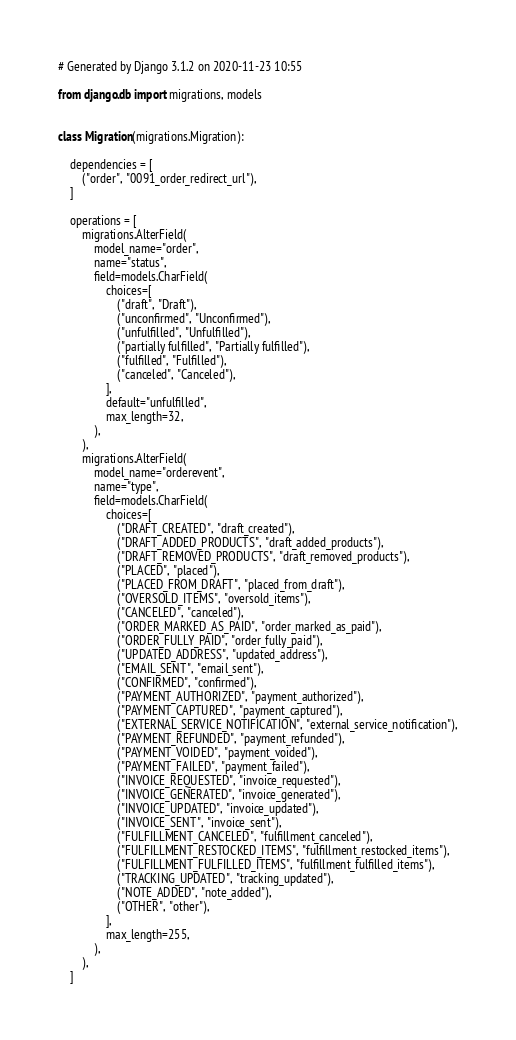<code> <loc_0><loc_0><loc_500><loc_500><_Python_># Generated by Django 3.1.2 on 2020-11-23 10:55

from django.db import migrations, models


class Migration(migrations.Migration):

    dependencies = [
        ("order", "0091_order_redirect_url"),
    ]

    operations = [
        migrations.AlterField(
            model_name="order",
            name="status",
            field=models.CharField(
                choices=[
                    ("draft", "Draft"),
                    ("unconfirmed", "Unconfirmed"),
                    ("unfulfilled", "Unfulfilled"),
                    ("partially fulfilled", "Partially fulfilled"),
                    ("fulfilled", "Fulfilled"),
                    ("canceled", "Canceled"),
                ],
                default="unfulfilled",
                max_length=32,
            ),
        ),
        migrations.AlterField(
            model_name="orderevent",
            name="type",
            field=models.CharField(
                choices=[
                    ("DRAFT_CREATED", "draft_created"),
                    ("DRAFT_ADDED_PRODUCTS", "draft_added_products"),
                    ("DRAFT_REMOVED_PRODUCTS", "draft_removed_products"),
                    ("PLACED", "placed"),
                    ("PLACED_FROM_DRAFT", "placed_from_draft"),
                    ("OVERSOLD_ITEMS", "oversold_items"),
                    ("CANCELED", "canceled"),
                    ("ORDER_MARKED_AS_PAID", "order_marked_as_paid"),
                    ("ORDER_FULLY_PAID", "order_fully_paid"),
                    ("UPDATED_ADDRESS", "updated_address"),
                    ("EMAIL_SENT", "email_sent"),
                    ("CONFIRMED", "confirmed"),
                    ("PAYMENT_AUTHORIZED", "payment_authorized"),
                    ("PAYMENT_CAPTURED", "payment_captured"),
                    ("EXTERNAL_SERVICE_NOTIFICATION", "external_service_notification"),
                    ("PAYMENT_REFUNDED", "payment_refunded"),
                    ("PAYMENT_VOIDED", "payment_voided"),
                    ("PAYMENT_FAILED", "payment_failed"),
                    ("INVOICE_REQUESTED", "invoice_requested"),
                    ("INVOICE_GENERATED", "invoice_generated"),
                    ("INVOICE_UPDATED", "invoice_updated"),
                    ("INVOICE_SENT", "invoice_sent"),
                    ("FULFILLMENT_CANCELED", "fulfillment_canceled"),
                    ("FULFILLMENT_RESTOCKED_ITEMS", "fulfillment_restocked_items"),
                    ("FULFILLMENT_FULFILLED_ITEMS", "fulfillment_fulfilled_items"),
                    ("TRACKING_UPDATED", "tracking_updated"),
                    ("NOTE_ADDED", "note_added"),
                    ("OTHER", "other"),
                ],
                max_length=255,
            ),
        ),
    ]
</code> 